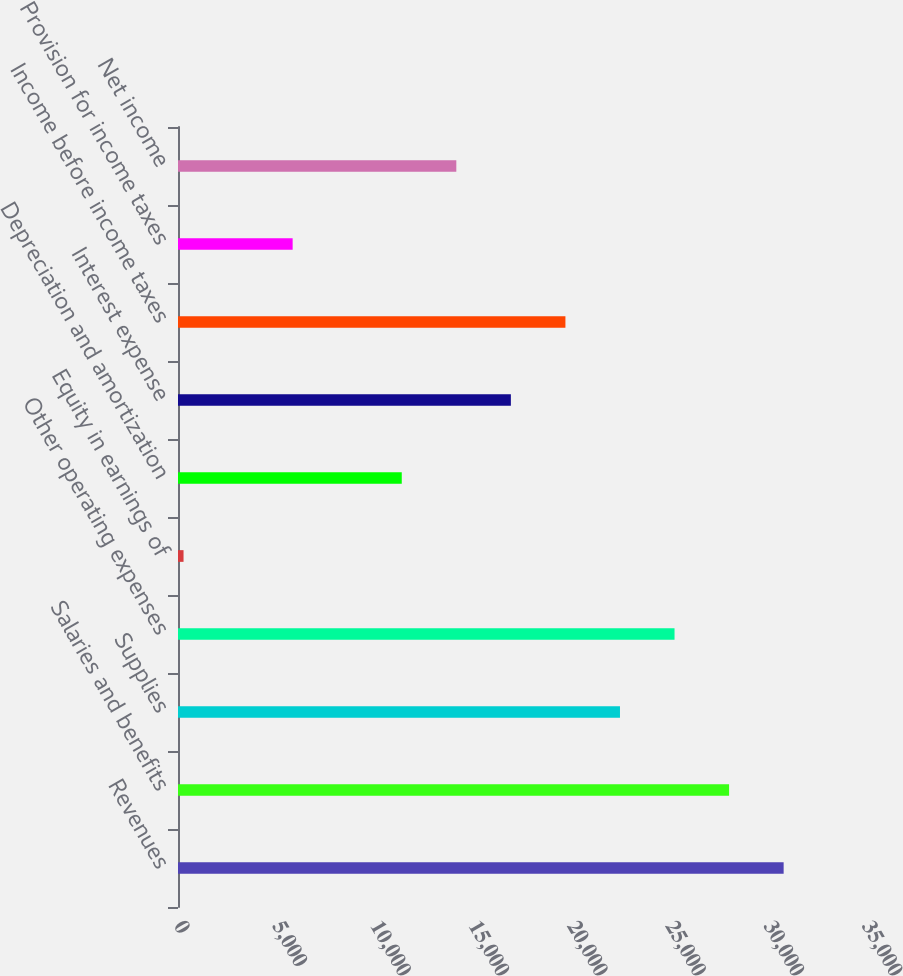<chart> <loc_0><loc_0><loc_500><loc_500><bar_chart><fcel>Revenues<fcel>Salaries and benefits<fcel>Supplies<fcel>Other operating expenses<fcel>Equity in earnings of<fcel>Depreciation and amortization<fcel>Interest expense<fcel>Income before income taxes<fcel>Provision for income taxes<fcel>Net income<nl><fcel>30810.3<fcel>28035<fcel>22484.4<fcel>25259.7<fcel>282<fcel>11383.2<fcel>16933.8<fcel>19709.1<fcel>5832.6<fcel>14158.5<nl></chart> 